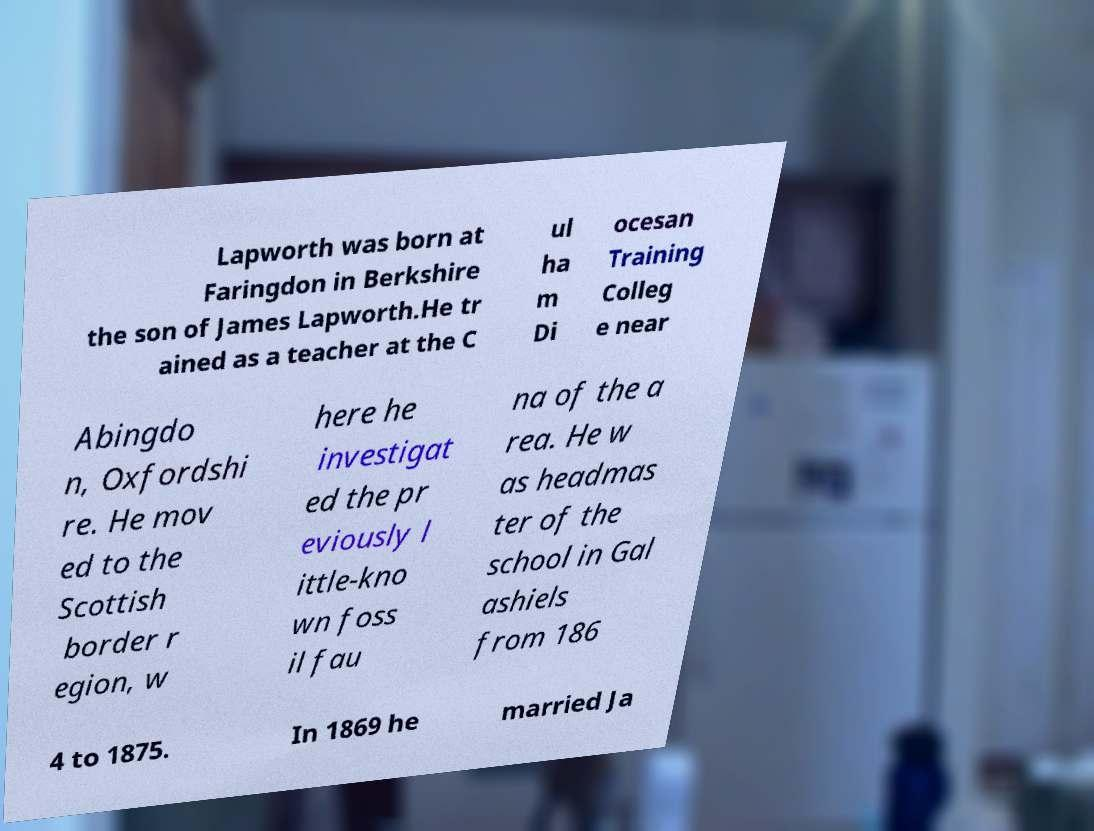Can you read and provide the text displayed in the image?This photo seems to have some interesting text. Can you extract and type it out for me? Lapworth was born at Faringdon in Berkshire the son of James Lapworth.He tr ained as a teacher at the C ul ha m Di ocesan Training Colleg e near Abingdo n, Oxfordshi re. He mov ed to the Scottish border r egion, w here he investigat ed the pr eviously l ittle-kno wn foss il fau na of the a rea. He w as headmas ter of the school in Gal ashiels from 186 4 to 1875. In 1869 he married Ja 